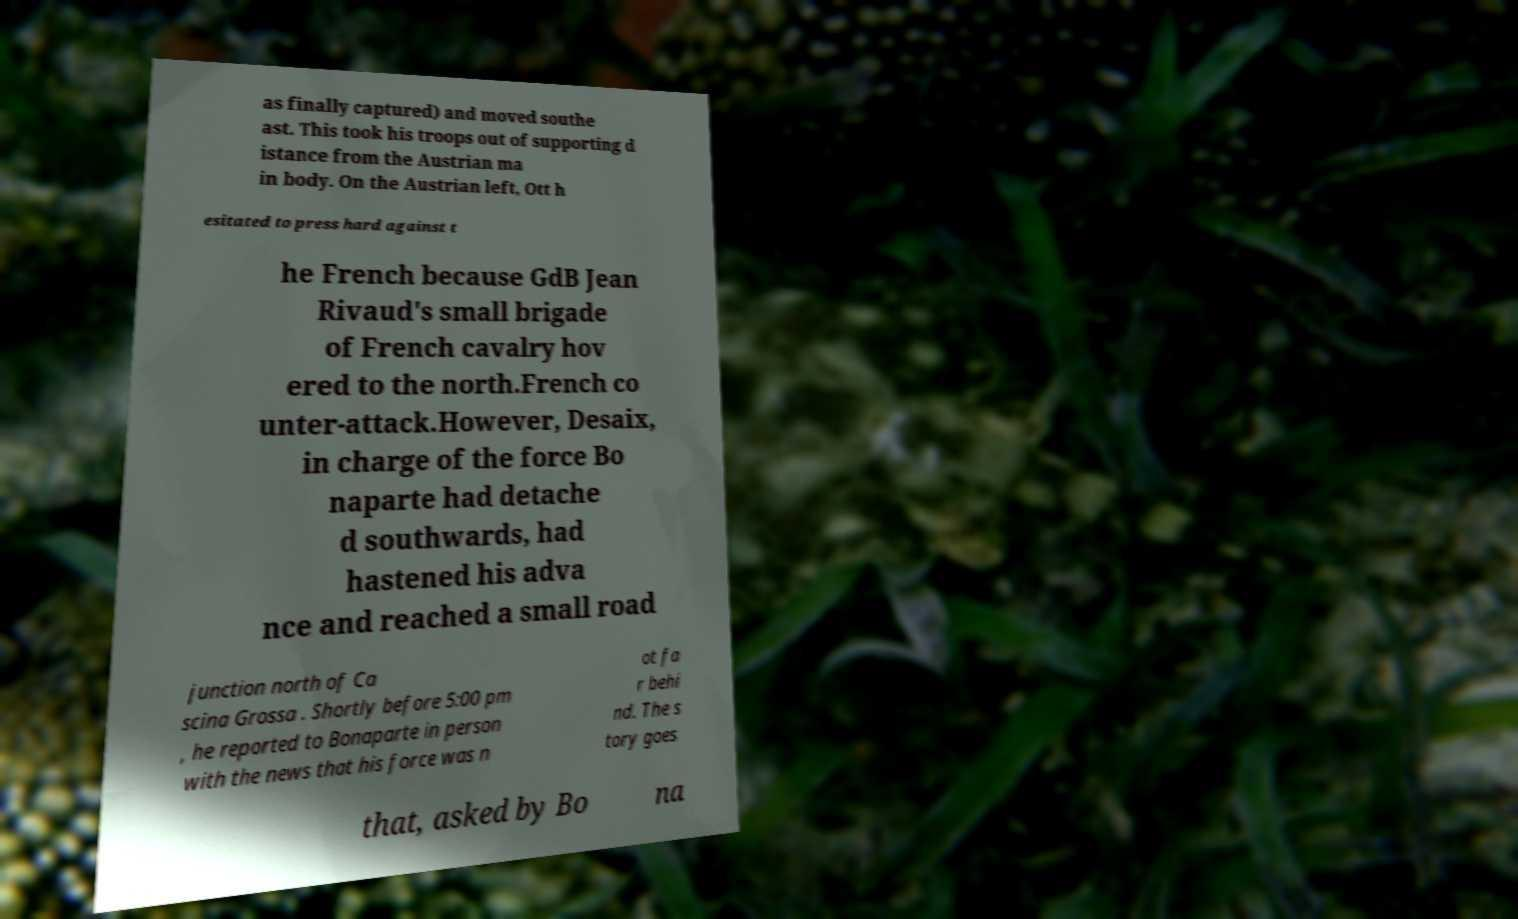Please read and relay the text visible in this image. What does it say? as finally captured) and moved southe ast. This took his troops out of supporting d istance from the Austrian ma in body. On the Austrian left, Ott h esitated to press hard against t he French because GdB Jean Rivaud's small brigade of French cavalry hov ered to the north.French co unter-attack.However, Desaix, in charge of the force Bo naparte had detache d southwards, had hastened his adva nce and reached a small road junction north of Ca scina Grossa . Shortly before 5:00 pm , he reported to Bonaparte in person with the news that his force was n ot fa r behi nd. The s tory goes that, asked by Bo na 